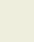<code> <loc_0><loc_0><loc_500><loc_500><_SQL_>  </code> 